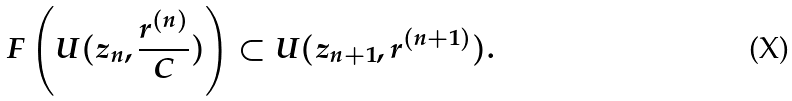Convert formula to latex. <formula><loc_0><loc_0><loc_500><loc_500>F \left ( U ( z _ { n } , \frac { r ^ { ( n ) } } { C } ) \right ) \subset U ( z _ { n + 1 } , r ^ { ( n + 1 ) } ) .</formula> 